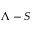Convert formula to latex. <formula><loc_0><loc_0><loc_500><loc_500>\Lambda - S</formula> 